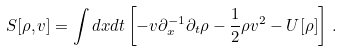<formula> <loc_0><loc_0><loc_500><loc_500>S [ \rho , v ] = \int d x d t \left [ - v \partial _ { x } ^ { - 1 } \partial _ { t } \rho - \frac { 1 } { 2 } \rho v ^ { 2 } - U [ \rho ] \right ] \, .</formula> 